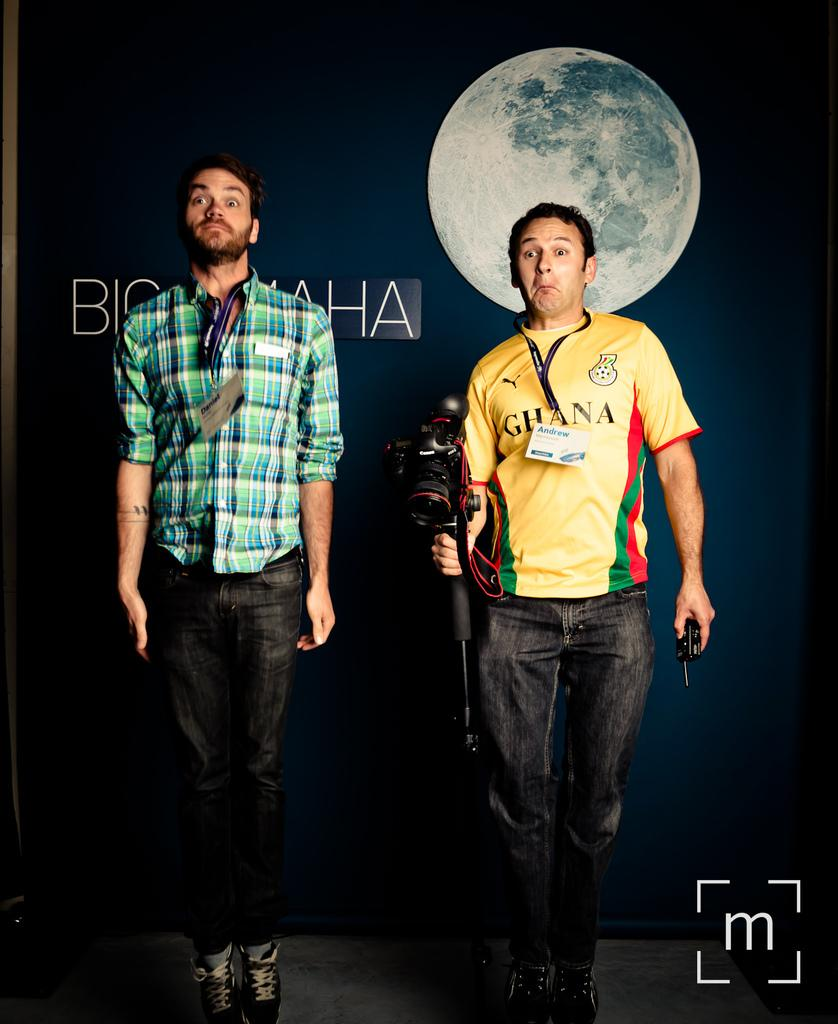<image>
Relay a brief, clear account of the picture shown. A man wears a yellow shirt with the word Ghana on it and stands next to another man. 